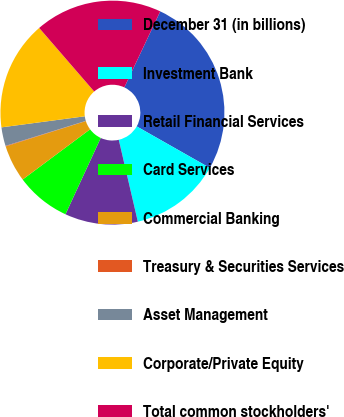<chart> <loc_0><loc_0><loc_500><loc_500><pie_chart><fcel>December 31 (in billions)<fcel>Investment Bank<fcel>Retail Financial Services<fcel>Card Services<fcel>Commercial Banking<fcel>Treasury & Securities Services<fcel>Asset Management<fcel>Corporate/Private Equity<fcel>Total common stockholders'<nl><fcel>26.2%<fcel>13.14%<fcel>10.53%<fcel>7.92%<fcel>5.31%<fcel>0.08%<fcel>2.7%<fcel>15.75%<fcel>18.37%<nl></chart> 